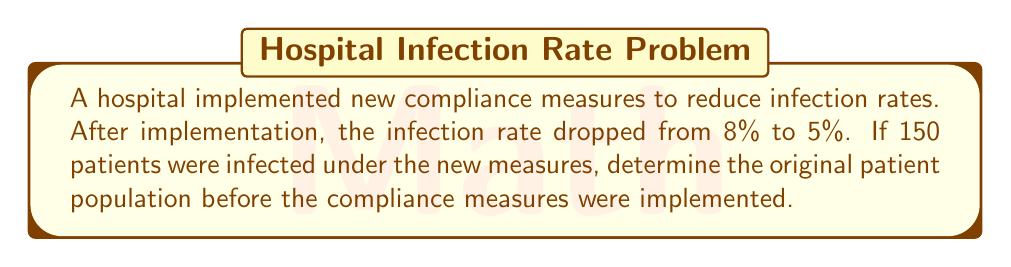Provide a solution to this math problem. Let's approach this step-by-step:

1) Let $x$ be the original patient population.

2) After implementation of new measures:
   - 5% of patients were infected
   - 150 patients were infected

3) We can set up the equation:
   $$ 0.05x = 150 $$

4) Solve for $x$:
   $$ x = \frac{150}{0.05} = 3000 $$

5) So, there were 3000 patients after the new measures.

6) Now, we need to find the original population before the measures:
   - The original infection rate was 8%
   - 3000 patients represent 92% of the original population (100% - 8%)

7) Let $y$ be the original population. We can set up the equation:
   $$ 0.92y = 3000 $$

8) Solve for $y$:
   $$ y = \frac{3000}{0.92} \approx 3261 $$

Therefore, the original patient population was approximately 3261 patients.
Answer: 3261 patients 